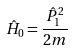Convert formula to latex. <formula><loc_0><loc_0><loc_500><loc_500>\hat { H } _ { 0 } = \frac { \hat { P } _ { 1 } ^ { 2 } } { 2 m }</formula> 